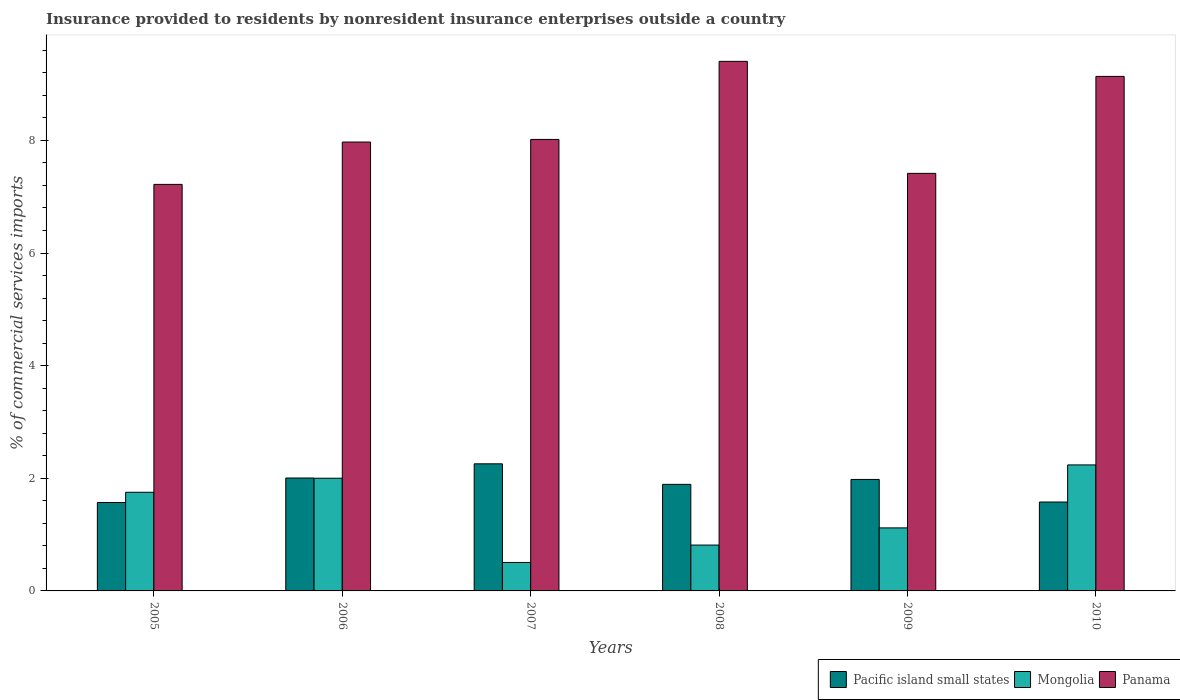How many different coloured bars are there?
Your response must be concise. 3. How many groups of bars are there?
Provide a short and direct response. 6. Are the number of bars on each tick of the X-axis equal?
Provide a short and direct response. Yes. How many bars are there on the 3rd tick from the left?
Provide a short and direct response. 3. What is the Insurance provided to residents in Panama in 2005?
Offer a very short reply. 7.22. Across all years, what is the maximum Insurance provided to residents in Panama?
Keep it short and to the point. 9.4. Across all years, what is the minimum Insurance provided to residents in Mongolia?
Provide a short and direct response. 0.51. In which year was the Insurance provided to residents in Mongolia minimum?
Provide a short and direct response. 2007. What is the total Insurance provided to residents in Pacific island small states in the graph?
Your answer should be compact. 11.28. What is the difference between the Insurance provided to residents in Panama in 2008 and that in 2010?
Give a very brief answer. 0.27. What is the difference between the Insurance provided to residents in Mongolia in 2008 and the Insurance provided to residents in Pacific island small states in 2009?
Your answer should be compact. -1.17. What is the average Insurance provided to residents in Pacific island small states per year?
Ensure brevity in your answer.  1.88. In the year 2009, what is the difference between the Insurance provided to residents in Panama and Insurance provided to residents in Mongolia?
Give a very brief answer. 6.3. In how many years, is the Insurance provided to residents in Panama greater than 2 %?
Offer a very short reply. 6. What is the ratio of the Insurance provided to residents in Pacific island small states in 2005 to that in 2009?
Your answer should be compact. 0.79. Is the Insurance provided to residents in Panama in 2005 less than that in 2010?
Your answer should be compact. Yes. What is the difference between the highest and the second highest Insurance provided to residents in Panama?
Offer a terse response. 0.27. What is the difference between the highest and the lowest Insurance provided to residents in Panama?
Make the answer very short. 2.18. What does the 3rd bar from the left in 2006 represents?
Keep it short and to the point. Panama. What does the 1st bar from the right in 2006 represents?
Offer a terse response. Panama. How many bars are there?
Offer a terse response. 18. How many years are there in the graph?
Provide a short and direct response. 6. What is the difference between two consecutive major ticks on the Y-axis?
Your response must be concise. 2. Are the values on the major ticks of Y-axis written in scientific E-notation?
Ensure brevity in your answer.  No. Does the graph contain any zero values?
Ensure brevity in your answer.  No. How many legend labels are there?
Offer a very short reply. 3. What is the title of the graph?
Your answer should be very brief. Insurance provided to residents by nonresident insurance enterprises outside a country. Does "Argentina" appear as one of the legend labels in the graph?
Provide a short and direct response. No. What is the label or title of the Y-axis?
Provide a succinct answer. % of commercial services imports. What is the % of commercial services imports in Pacific island small states in 2005?
Provide a succinct answer. 1.57. What is the % of commercial services imports of Mongolia in 2005?
Your response must be concise. 1.75. What is the % of commercial services imports of Panama in 2005?
Your response must be concise. 7.22. What is the % of commercial services imports in Pacific island small states in 2006?
Make the answer very short. 2. What is the % of commercial services imports in Mongolia in 2006?
Your answer should be very brief. 2. What is the % of commercial services imports of Panama in 2006?
Provide a succinct answer. 7.97. What is the % of commercial services imports in Pacific island small states in 2007?
Offer a terse response. 2.26. What is the % of commercial services imports of Mongolia in 2007?
Your answer should be compact. 0.51. What is the % of commercial services imports in Panama in 2007?
Offer a very short reply. 8.02. What is the % of commercial services imports in Pacific island small states in 2008?
Your response must be concise. 1.89. What is the % of commercial services imports in Mongolia in 2008?
Keep it short and to the point. 0.81. What is the % of commercial services imports in Panama in 2008?
Your answer should be very brief. 9.4. What is the % of commercial services imports in Pacific island small states in 2009?
Your answer should be compact. 1.98. What is the % of commercial services imports in Mongolia in 2009?
Offer a very short reply. 1.12. What is the % of commercial services imports of Panama in 2009?
Provide a succinct answer. 7.41. What is the % of commercial services imports of Pacific island small states in 2010?
Give a very brief answer. 1.58. What is the % of commercial services imports of Mongolia in 2010?
Your response must be concise. 2.24. What is the % of commercial services imports in Panama in 2010?
Keep it short and to the point. 9.14. Across all years, what is the maximum % of commercial services imports of Pacific island small states?
Keep it short and to the point. 2.26. Across all years, what is the maximum % of commercial services imports of Mongolia?
Provide a short and direct response. 2.24. Across all years, what is the maximum % of commercial services imports of Panama?
Make the answer very short. 9.4. Across all years, what is the minimum % of commercial services imports of Pacific island small states?
Offer a very short reply. 1.57. Across all years, what is the minimum % of commercial services imports of Mongolia?
Your response must be concise. 0.51. Across all years, what is the minimum % of commercial services imports of Panama?
Give a very brief answer. 7.22. What is the total % of commercial services imports of Pacific island small states in the graph?
Give a very brief answer. 11.28. What is the total % of commercial services imports of Mongolia in the graph?
Keep it short and to the point. 8.43. What is the total % of commercial services imports in Panama in the graph?
Provide a short and direct response. 49.16. What is the difference between the % of commercial services imports in Pacific island small states in 2005 and that in 2006?
Offer a very short reply. -0.43. What is the difference between the % of commercial services imports of Mongolia in 2005 and that in 2006?
Make the answer very short. -0.25. What is the difference between the % of commercial services imports of Panama in 2005 and that in 2006?
Your response must be concise. -0.75. What is the difference between the % of commercial services imports of Pacific island small states in 2005 and that in 2007?
Ensure brevity in your answer.  -0.69. What is the difference between the % of commercial services imports of Mongolia in 2005 and that in 2007?
Offer a very short reply. 1.25. What is the difference between the % of commercial services imports of Panama in 2005 and that in 2007?
Provide a succinct answer. -0.8. What is the difference between the % of commercial services imports in Pacific island small states in 2005 and that in 2008?
Your answer should be very brief. -0.32. What is the difference between the % of commercial services imports in Mongolia in 2005 and that in 2008?
Offer a terse response. 0.94. What is the difference between the % of commercial services imports in Panama in 2005 and that in 2008?
Your answer should be very brief. -2.18. What is the difference between the % of commercial services imports in Pacific island small states in 2005 and that in 2009?
Give a very brief answer. -0.41. What is the difference between the % of commercial services imports of Mongolia in 2005 and that in 2009?
Ensure brevity in your answer.  0.63. What is the difference between the % of commercial services imports of Panama in 2005 and that in 2009?
Keep it short and to the point. -0.2. What is the difference between the % of commercial services imports of Pacific island small states in 2005 and that in 2010?
Your answer should be compact. -0.01. What is the difference between the % of commercial services imports of Mongolia in 2005 and that in 2010?
Offer a terse response. -0.49. What is the difference between the % of commercial services imports of Panama in 2005 and that in 2010?
Give a very brief answer. -1.92. What is the difference between the % of commercial services imports of Pacific island small states in 2006 and that in 2007?
Your response must be concise. -0.25. What is the difference between the % of commercial services imports in Mongolia in 2006 and that in 2007?
Offer a terse response. 1.5. What is the difference between the % of commercial services imports in Panama in 2006 and that in 2007?
Provide a succinct answer. -0.05. What is the difference between the % of commercial services imports in Pacific island small states in 2006 and that in 2008?
Your answer should be compact. 0.11. What is the difference between the % of commercial services imports in Mongolia in 2006 and that in 2008?
Make the answer very short. 1.19. What is the difference between the % of commercial services imports in Panama in 2006 and that in 2008?
Ensure brevity in your answer.  -1.43. What is the difference between the % of commercial services imports of Pacific island small states in 2006 and that in 2009?
Your answer should be very brief. 0.03. What is the difference between the % of commercial services imports of Mongolia in 2006 and that in 2009?
Your response must be concise. 0.88. What is the difference between the % of commercial services imports in Panama in 2006 and that in 2009?
Your response must be concise. 0.56. What is the difference between the % of commercial services imports of Pacific island small states in 2006 and that in 2010?
Offer a terse response. 0.43. What is the difference between the % of commercial services imports in Mongolia in 2006 and that in 2010?
Provide a short and direct response. -0.24. What is the difference between the % of commercial services imports of Panama in 2006 and that in 2010?
Ensure brevity in your answer.  -1.17. What is the difference between the % of commercial services imports of Pacific island small states in 2007 and that in 2008?
Offer a very short reply. 0.36. What is the difference between the % of commercial services imports in Mongolia in 2007 and that in 2008?
Ensure brevity in your answer.  -0.31. What is the difference between the % of commercial services imports in Panama in 2007 and that in 2008?
Offer a terse response. -1.39. What is the difference between the % of commercial services imports in Pacific island small states in 2007 and that in 2009?
Give a very brief answer. 0.28. What is the difference between the % of commercial services imports of Mongolia in 2007 and that in 2009?
Your response must be concise. -0.61. What is the difference between the % of commercial services imports of Panama in 2007 and that in 2009?
Your response must be concise. 0.6. What is the difference between the % of commercial services imports of Pacific island small states in 2007 and that in 2010?
Make the answer very short. 0.68. What is the difference between the % of commercial services imports in Mongolia in 2007 and that in 2010?
Your response must be concise. -1.73. What is the difference between the % of commercial services imports of Panama in 2007 and that in 2010?
Your answer should be very brief. -1.12. What is the difference between the % of commercial services imports in Pacific island small states in 2008 and that in 2009?
Keep it short and to the point. -0.09. What is the difference between the % of commercial services imports in Mongolia in 2008 and that in 2009?
Offer a very short reply. -0.3. What is the difference between the % of commercial services imports in Panama in 2008 and that in 2009?
Your response must be concise. 1.99. What is the difference between the % of commercial services imports of Pacific island small states in 2008 and that in 2010?
Ensure brevity in your answer.  0.31. What is the difference between the % of commercial services imports in Mongolia in 2008 and that in 2010?
Offer a terse response. -1.42. What is the difference between the % of commercial services imports in Panama in 2008 and that in 2010?
Offer a terse response. 0.27. What is the difference between the % of commercial services imports of Pacific island small states in 2009 and that in 2010?
Make the answer very short. 0.4. What is the difference between the % of commercial services imports of Mongolia in 2009 and that in 2010?
Your answer should be very brief. -1.12. What is the difference between the % of commercial services imports of Panama in 2009 and that in 2010?
Your answer should be very brief. -1.72. What is the difference between the % of commercial services imports of Pacific island small states in 2005 and the % of commercial services imports of Mongolia in 2006?
Offer a terse response. -0.43. What is the difference between the % of commercial services imports of Pacific island small states in 2005 and the % of commercial services imports of Panama in 2006?
Offer a very short reply. -6.4. What is the difference between the % of commercial services imports in Mongolia in 2005 and the % of commercial services imports in Panama in 2006?
Offer a terse response. -6.22. What is the difference between the % of commercial services imports in Pacific island small states in 2005 and the % of commercial services imports in Mongolia in 2007?
Your response must be concise. 1.07. What is the difference between the % of commercial services imports of Pacific island small states in 2005 and the % of commercial services imports of Panama in 2007?
Offer a very short reply. -6.45. What is the difference between the % of commercial services imports of Mongolia in 2005 and the % of commercial services imports of Panama in 2007?
Your response must be concise. -6.27. What is the difference between the % of commercial services imports of Pacific island small states in 2005 and the % of commercial services imports of Mongolia in 2008?
Your answer should be very brief. 0.76. What is the difference between the % of commercial services imports of Pacific island small states in 2005 and the % of commercial services imports of Panama in 2008?
Offer a very short reply. -7.83. What is the difference between the % of commercial services imports in Mongolia in 2005 and the % of commercial services imports in Panama in 2008?
Offer a very short reply. -7.65. What is the difference between the % of commercial services imports in Pacific island small states in 2005 and the % of commercial services imports in Mongolia in 2009?
Make the answer very short. 0.45. What is the difference between the % of commercial services imports in Pacific island small states in 2005 and the % of commercial services imports in Panama in 2009?
Provide a short and direct response. -5.84. What is the difference between the % of commercial services imports of Mongolia in 2005 and the % of commercial services imports of Panama in 2009?
Your response must be concise. -5.66. What is the difference between the % of commercial services imports in Pacific island small states in 2005 and the % of commercial services imports in Mongolia in 2010?
Your response must be concise. -0.67. What is the difference between the % of commercial services imports of Pacific island small states in 2005 and the % of commercial services imports of Panama in 2010?
Keep it short and to the point. -7.57. What is the difference between the % of commercial services imports in Mongolia in 2005 and the % of commercial services imports in Panama in 2010?
Your response must be concise. -7.38. What is the difference between the % of commercial services imports in Pacific island small states in 2006 and the % of commercial services imports in Mongolia in 2007?
Your response must be concise. 1.5. What is the difference between the % of commercial services imports in Pacific island small states in 2006 and the % of commercial services imports in Panama in 2007?
Your answer should be compact. -6.01. What is the difference between the % of commercial services imports of Mongolia in 2006 and the % of commercial services imports of Panama in 2007?
Give a very brief answer. -6.02. What is the difference between the % of commercial services imports of Pacific island small states in 2006 and the % of commercial services imports of Mongolia in 2008?
Give a very brief answer. 1.19. What is the difference between the % of commercial services imports in Pacific island small states in 2006 and the % of commercial services imports in Panama in 2008?
Offer a terse response. -7.4. What is the difference between the % of commercial services imports of Mongolia in 2006 and the % of commercial services imports of Panama in 2008?
Offer a terse response. -7.4. What is the difference between the % of commercial services imports in Pacific island small states in 2006 and the % of commercial services imports in Mongolia in 2009?
Provide a short and direct response. 0.89. What is the difference between the % of commercial services imports in Pacific island small states in 2006 and the % of commercial services imports in Panama in 2009?
Offer a terse response. -5.41. What is the difference between the % of commercial services imports in Mongolia in 2006 and the % of commercial services imports in Panama in 2009?
Your response must be concise. -5.41. What is the difference between the % of commercial services imports of Pacific island small states in 2006 and the % of commercial services imports of Mongolia in 2010?
Provide a succinct answer. -0.23. What is the difference between the % of commercial services imports of Pacific island small states in 2006 and the % of commercial services imports of Panama in 2010?
Your answer should be compact. -7.13. What is the difference between the % of commercial services imports in Mongolia in 2006 and the % of commercial services imports in Panama in 2010?
Provide a short and direct response. -7.13. What is the difference between the % of commercial services imports of Pacific island small states in 2007 and the % of commercial services imports of Mongolia in 2008?
Your response must be concise. 1.44. What is the difference between the % of commercial services imports of Pacific island small states in 2007 and the % of commercial services imports of Panama in 2008?
Make the answer very short. -7.15. What is the difference between the % of commercial services imports of Mongolia in 2007 and the % of commercial services imports of Panama in 2008?
Your answer should be compact. -8.9. What is the difference between the % of commercial services imports of Pacific island small states in 2007 and the % of commercial services imports of Mongolia in 2009?
Offer a very short reply. 1.14. What is the difference between the % of commercial services imports of Pacific island small states in 2007 and the % of commercial services imports of Panama in 2009?
Your response must be concise. -5.16. What is the difference between the % of commercial services imports of Mongolia in 2007 and the % of commercial services imports of Panama in 2009?
Keep it short and to the point. -6.91. What is the difference between the % of commercial services imports of Pacific island small states in 2007 and the % of commercial services imports of Mongolia in 2010?
Give a very brief answer. 0.02. What is the difference between the % of commercial services imports of Pacific island small states in 2007 and the % of commercial services imports of Panama in 2010?
Offer a terse response. -6.88. What is the difference between the % of commercial services imports of Mongolia in 2007 and the % of commercial services imports of Panama in 2010?
Make the answer very short. -8.63. What is the difference between the % of commercial services imports in Pacific island small states in 2008 and the % of commercial services imports in Mongolia in 2009?
Make the answer very short. 0.77. What is the difference between the % of commercial services imports of Pacific island small states in 2008 and the % of commercial services imports of Panama in 2009?
Keep it short and to the point. -5.52. What is the difference between the % of commercial services imports in Mongolia in 2008 and the % of commercial services imports in Panama in 2009?
Your answer should be very brief. -6.6. What is the difference between the % of commercial services imports of Pacific island small states in 2008 and the % of commercial services imports of Mongolia in 2010?
Provide a succinct answer. -0.35. What is the difference between the % of commercial services imports in Pacific island small states in 2008 and the % of commercial services imports in Panama in 2010?
Your answer should be very brief. -7.24. What is the difference between the % of commercial services imports in Mongolia in 2008 and the % of commercial services imports in Panama in 2010?
Your answer should be compact. -8.32. What is the difference between the % of commercial services imports in Pacific island small states in 2009 and the % of commercial services imports in Mongolia in 2010?
Provide a short and direct response. -0.26. What is the difference between the % of commercial services imports in Pacific island small states in 2009 and the % of commercial services imports in Panama in 2010?
Keep it short and to the point. -7.16. What is the difference between the % of commercial services imports in Mongolia in 2009 and the % of commercial services imports in Panama in 2010?
Your answer should be compact. -8.02. What is the average % of commercial services imports of Pacific island small states per year?
Make the answer very short. 1.88. What is the average % of commercial services imports in Mongolia per year?
Ensure brevity in your answer.  1.4. What is the average % of commercial services imports in Panama per year?
Your response must be concise. 8.19. In the year 2005, what is the difference between the % of commercial services imports of Pacific island small states and % of commercial services imports of Mongolia?
Provide a succinct answer. -0.18. In the year 2005, what is the difference between the % of commercial services imports of Pacific island small states and % of commercial services imports of Panama?
Make the answer very short. -5.65. In the year 2005, what is the difference between the % of commercial services imports in Mongolia and % of commercial services imports in Panama?
Provide a succinct answer. -5.47. In the year 2006, what is the difference between the % of commercial services imports of Pacific island small states and % of commercial services imports of Mongolia?
Give a very brief answer. 0. In the year 2006, what is the difference between the % of commercial services imports of Pacific island small states and % of commercial services imports of Panama?
Give a very brief answer. -5.97. In the year 2006, what is the difference between the % of commercial services imports in Mongolia and % of commercial services imports in Panama?
Provide a short and direct response. -5.97. In the year 2007, what is the difference between the % of commercial services imports of Pacific island small states and % of commercial services imports of Mongolia?
Offer a very short reply. 1.75. In the year 2007, what is the difference between the % of commercial services imports in Pacific island small states and % of commercial services imports in Panama?
Your answer should be compact. -5.76. In the year 2007, what is the difference between the % of commercial services imports of Mongolia and % of commercial services imports of Panama?
Provide a short and direct response. -7.51. In the year 2008, what is the difference between the % of commercial services imports in Pacific island small states and % of commercial services imports in Mongolia?
Offer a very short reply. 1.08. In the year 2008, what is the difference between the % of commercial services imports in Pacific island small states and % of commercial services imports in Panama?
Make the answer very short. -7.51. In the year 2008, what is the difference between the % of commercial services imports in Mongolia and % of commercial services imports in Panama?
Your response must be concise. -8.59. In the year 2009, what is the difference between the % of commercial services imports in Pacific island small states and % of commercial services imports in Mongolia?
Make the answer very short. 0.86. In the year 2009, what is the difference between the % of commercial services imports of Pacific island small states and % of commercial services imports of Panama?
Ensure brevity in your answer.  -5.43. In the year 2009, what is the difference between the % of commercial services imports in Mongolia and % of commercial services imports in Panama?
Your response must be concise. -6.3. In the year 2010, what is the difference between the % of commercial services imports in Pacific island small states and % of commercial services imports in Mongolia?
Keep it short and to the point. -0.66. In the year 2010, what is the difference between the % of commercial services imports of Pacific island small states and % of commercial services imports of Panama?
Give a very brief answer. -7.56. In the year 2010, what is the difference between the % of commercial services imports in Mongolia and % of commercial services imports in Panama?
Offer a very short reply. -6.9. What is the ratio of the % of commercial services imports in Pacific island small states in 2005 to that in 2006?
Keep it short and to the point. 0.78. What is the ratio of the % of commercial services imports in Mongolia in 2005 to that in 2006?
Offer a very short reply. 0.88. What is the ratio of the % of commercial services imports in Panama in 2005 to that in 2006?
Your answer should be compact. 0.91. What is the ratio of the % of commercial services imports of Pacific island small states in 2005 to that in 2007?
Your answer should be compact. 0.7. What is the ratio of the % of commercial services imports in Mongolia in 2005 to that in 2007?
Your answer should be very brief. 3.46. What is the ratio of the % of commercial services imports in Panama in 2005 to that in 2007?
Ensure brevity in your answer.  0.9. What is the ratio of the % of commercial services imports of Pacific island small states in 2005 to that in 2008?
Ensure brevity in your answer.  0.83. What is the ratio of the % of commercial services imports of Mongolia in 2005 to that in 2008?
Your answer should be compact. 2.15. What is the ratio of the % of commercial services imports of Panama in 2005 to that in 2008?
Give a very brief answer. 0.77. What is the ratio of the % of commercial services imports in Pacific island small states in 2005 to that in 2009?
Provide a succinct answer. 0.79. What is the ratio of the % of commercial services imports of Mongolia in 2005 to that in 2009?
Keep it short and to the point. 1.57. What is the ratio of the % of commercial services imports of Panama in 2005 to that in 2009?
Offer a very short reply. 0.97. What is the ratio of the % of commercial services imports in Pacific island small states in 2005 to that in 2010?
Keep it short and to the point. 0.99. What is the ratio of the % of commercial services imports in Mongolia in 2005 to that in 2010?
Your answer should be very brief. 0.78. What is the ratio of the % of commercial services imports of Panama in 2005 to that in 2010?
Keep it short and to the point. 0.79. What is the ratio of the % of commercial services imports of Pacific island small states in 2006 to that in 2007?
Make the answer very short. 0.89. What is the ratio of the % of commercial services imports of Mongolia in 2006 to that in 2007?
Your answer should be compact. 3.96. What is the ratio of the % of commercial services imports in Pacific island small states in 2006 to that in 2008?
Offer a terse response. 1.06. What is the ratio of the % of commercial services imports of Mongolia in 2006 to that in 2008?
Your answer should be compact. 2.46. What is the ratio of the % of commercial services imports of Panama in 2006 to that in 2008?
Ensure brevity in your answer.  0.85. What is the ratio of the % of commercial services imports of Pacific island small states in 2006 to that in 2009?
Keep it short and to the point. 1.01. What is the ratio of the % of commercial services imports in Mongolia in 2006 to that in 2009?
Provide a succinct answer. 1.79. What is the ratio of the % of commercial services imports in Panama in 2006 to that in 2009?
Make the answer very short. 1.07. What is the ratio of the % of commercial services imports of Pacific island small states in 2006 to that in 2010?
Provide a succinct answer. 1.27. What is the ratio of the % of commercial services imports of Mongolia in 2006 to that in 2010?
Make the answer very short. 0.89. What is the ratio of the % of commercial services imports in Panama in 2006 to that in 2010?
Your answer should be compact. 0.87. What is the ratio of the % of commercial services imports in Pacific island small states in 2007 to that in 2008?
Your answer should be very brief. 1.19. What is the ratio of the % of commercial services imports in Mongolia in 2007 to that in 2008?
Offer a very short reply. 0.62. What is the ratio of the % of commercial services imports in Panama in 2007 to that in 2008?
Provide a succinct answer. 0.85. What is the ratio of the % of commercial services imports of Pacific island small states in 2007 to that in 2009?
Keep it short and to the point. 1.14. What is the ratio of the % of commercial services imports in Mongolia in 2007 to that in 2009?
Your answer should be very brief. 0.45. What is the ratio of the % of commercial services imports of Panama in 2007 to that in 2009?
Offer a terse response. 1.08. What is the ratio of the % of commercial services imports of Pacific island small states in 2007 to that in 2010?
Ensure brevity in your answer.  1.43. What is the ratio of the % of commercial services imports in Mongolia in 2007 to that in 2010?
Give a very brief answer. 0.23. What is the ratio of the % of commercial services imports of Panama in 2007 to that in 2010?
Make the answer very short. 0.88. What is the ratio of the % of commercial services imports of Pacific island small states in 2008 to that in 2009?
Ensure brevity in your answer.  0.96. What is the ratio of the % of commercial services imports in Mongolia in 2008 to that in 2009?
Your answer should be very brief. 0.73. What is the ratio of the % of commercial services imports in Panama in 2008 to that in 2009?
Provide a succinct answer. 1.27. What is the ratio of the % of commercial services imports in Pacific island small states in 2008 to that in 2010?
Provide a short and direct response. 1.2. What is the ratio of the % of commercial services imports in Mongolia in 2008 to that in 2010?
Your response must be concise. 0.36. What is the ratio of the % of commercial services imports in Panama in 2008 to that in 2010?
Provide a succinct answer. 1.03. What is the ratio of the % of commercial services imports of Pacific island small states in 2009 to that in 2010?
Keep it short and to the point. 1.25. What is the ratio of the % of commercial services imports in Mongolia in 2009 to that in 2010?
Keep it short and to the point. 0.5. What is the ratio of the % of commercial services imports of Panama in 2009 to that in 2010?
Your answer should be very brief. 0.81. What is the difference between the highest and the second highest % of commercial services imports of Pacific island small states?
Make the answer very short. 0.25. What is the difference between the highest and the second highest % of commercial services imports in Mongolia?
Offer a terse response. 0.24. What is the difference between the highest and the second highest % of commercial services imports of Panama?
Your response must be concise. 0.27. What is the difference between the highest and the lowest % of commercial services imports of Pacific island small states?
Provide a short and direct response. 0.69. What is the difference between the highest and the lowest % of commercial services imports of Mongolia?
Your answer should be very brief. 1.73. What is the difference between the highest and the lowest % of commercial services imports of Panama?
Give a very brief answer. 2.18. 